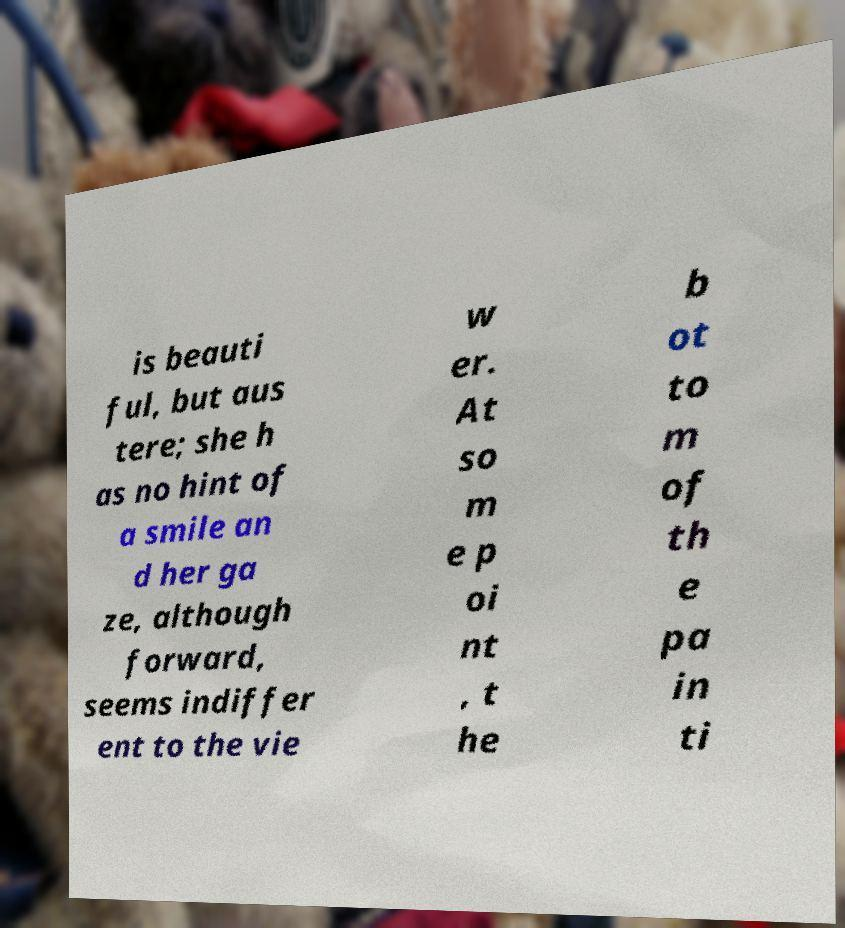Please read and relay the text visible in this image. What does it say? is beauti ful, but aus tere; she h as no hint of a smile an d her ga ze, although forward, seems indiffer ent to the vie w er. At so m e p oi nt , t he b ot to m of th e pa in ti 